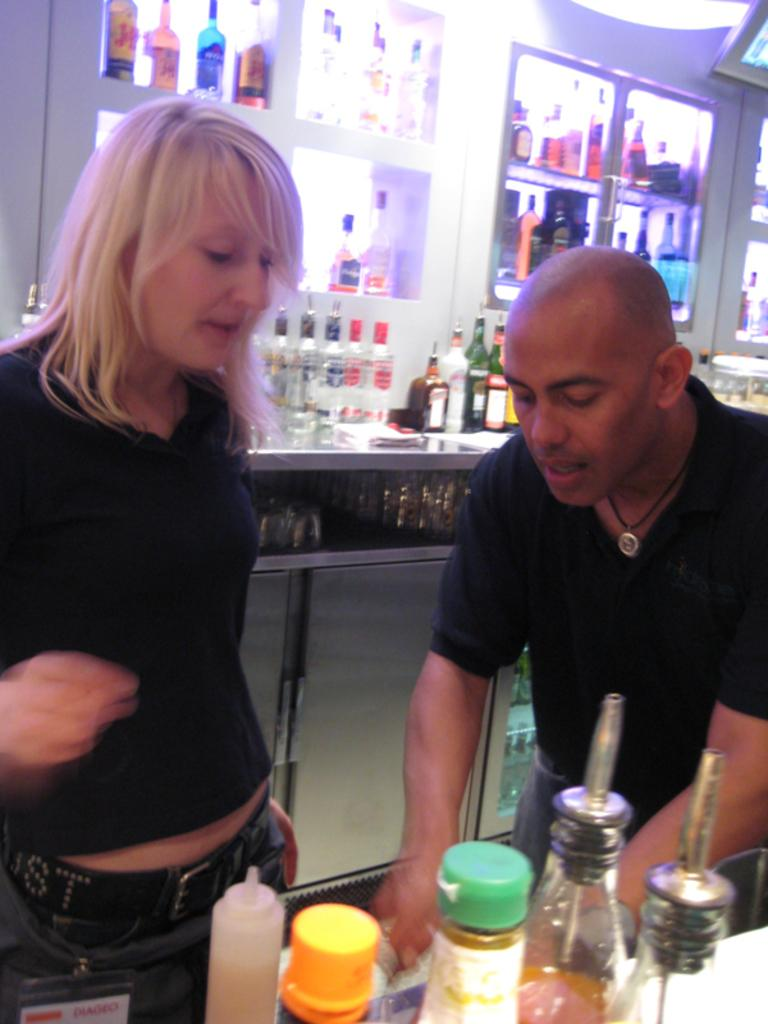What is happening in the image? There are people standing in the image. What objects can be seen near the people? There are wine bottles visible in the image. What type of jewel is being used to set the rhythm in the image? There is no mention of a jewel or rhythm in the image; it only shows people standing and wine bottles. 